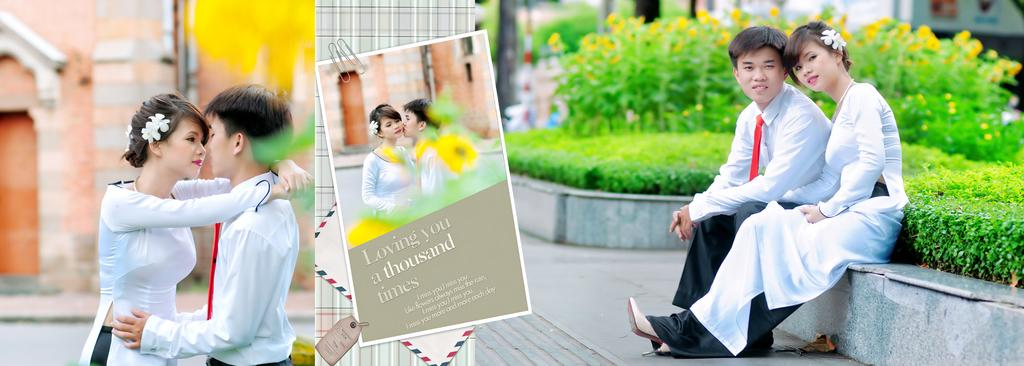Who are the people in the image? The image contains the same people. What type of vegetation is present in the image? There are plants and flowers in the image. What can be found attached to the plants or flowers? There is a tag in the image. How would you describe the background of the image? The background of the image is blurred. What type of soap can be seen in the image? There is no soap present in the image. How many ants are visible on the flowers in the image? There are no ants visible in the image; it only contains plants, flowers, and a tag. 